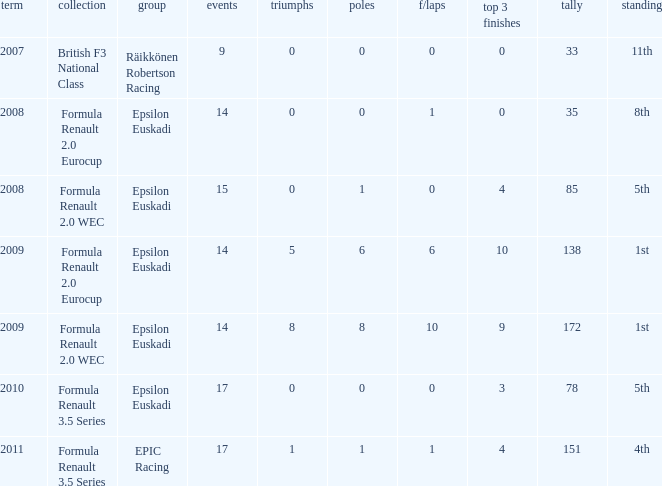Help me parse the entirety of this table. {'header': ['term', 'collection', 'group', 'events', 'triumphs', 'poles', 'f/laps', 'top 3 finishes', 'tally', 'standing'], 'rows': [['2007', 'British F3 National Class', 'Räikkönen Robertson Racing', '9', '0', '0', '0', '0', '33', '11th'], ['2008', 'Formula Renault 2.0 Eurocup', 'Epsilon Euskadi', '14', '0', '0', '1', '0', '35', '8th'], ['2008', 'Formula Renault 2.0 WEC', 'Epsilon Euskadi', '15', '0', '1', '0', '4', '85', '5th'], ['2009', 'Formula Renault 2.0 Eurocup', 'Epsilon Euskadi', '14', '5', '6', '6', '10', '138', '1st'], ['2009', 'Formula Renault 2.0 WEC', 'Epsilon Euskadi', '14', '8', '8', '10', '9', '172', '1st'], ['2010', 'Formula Renault 3.5 Series', 'Epsilon Euskadi', '17', '0', '0', '0', '3', '78', '5th'], ['2011', 'Formula Renault 3.5 Series', 'EPIC Racing', '17', '1', '1', '1', '4', '151', '4th']]} How many f/laps when he finished 8th? 1.0. 